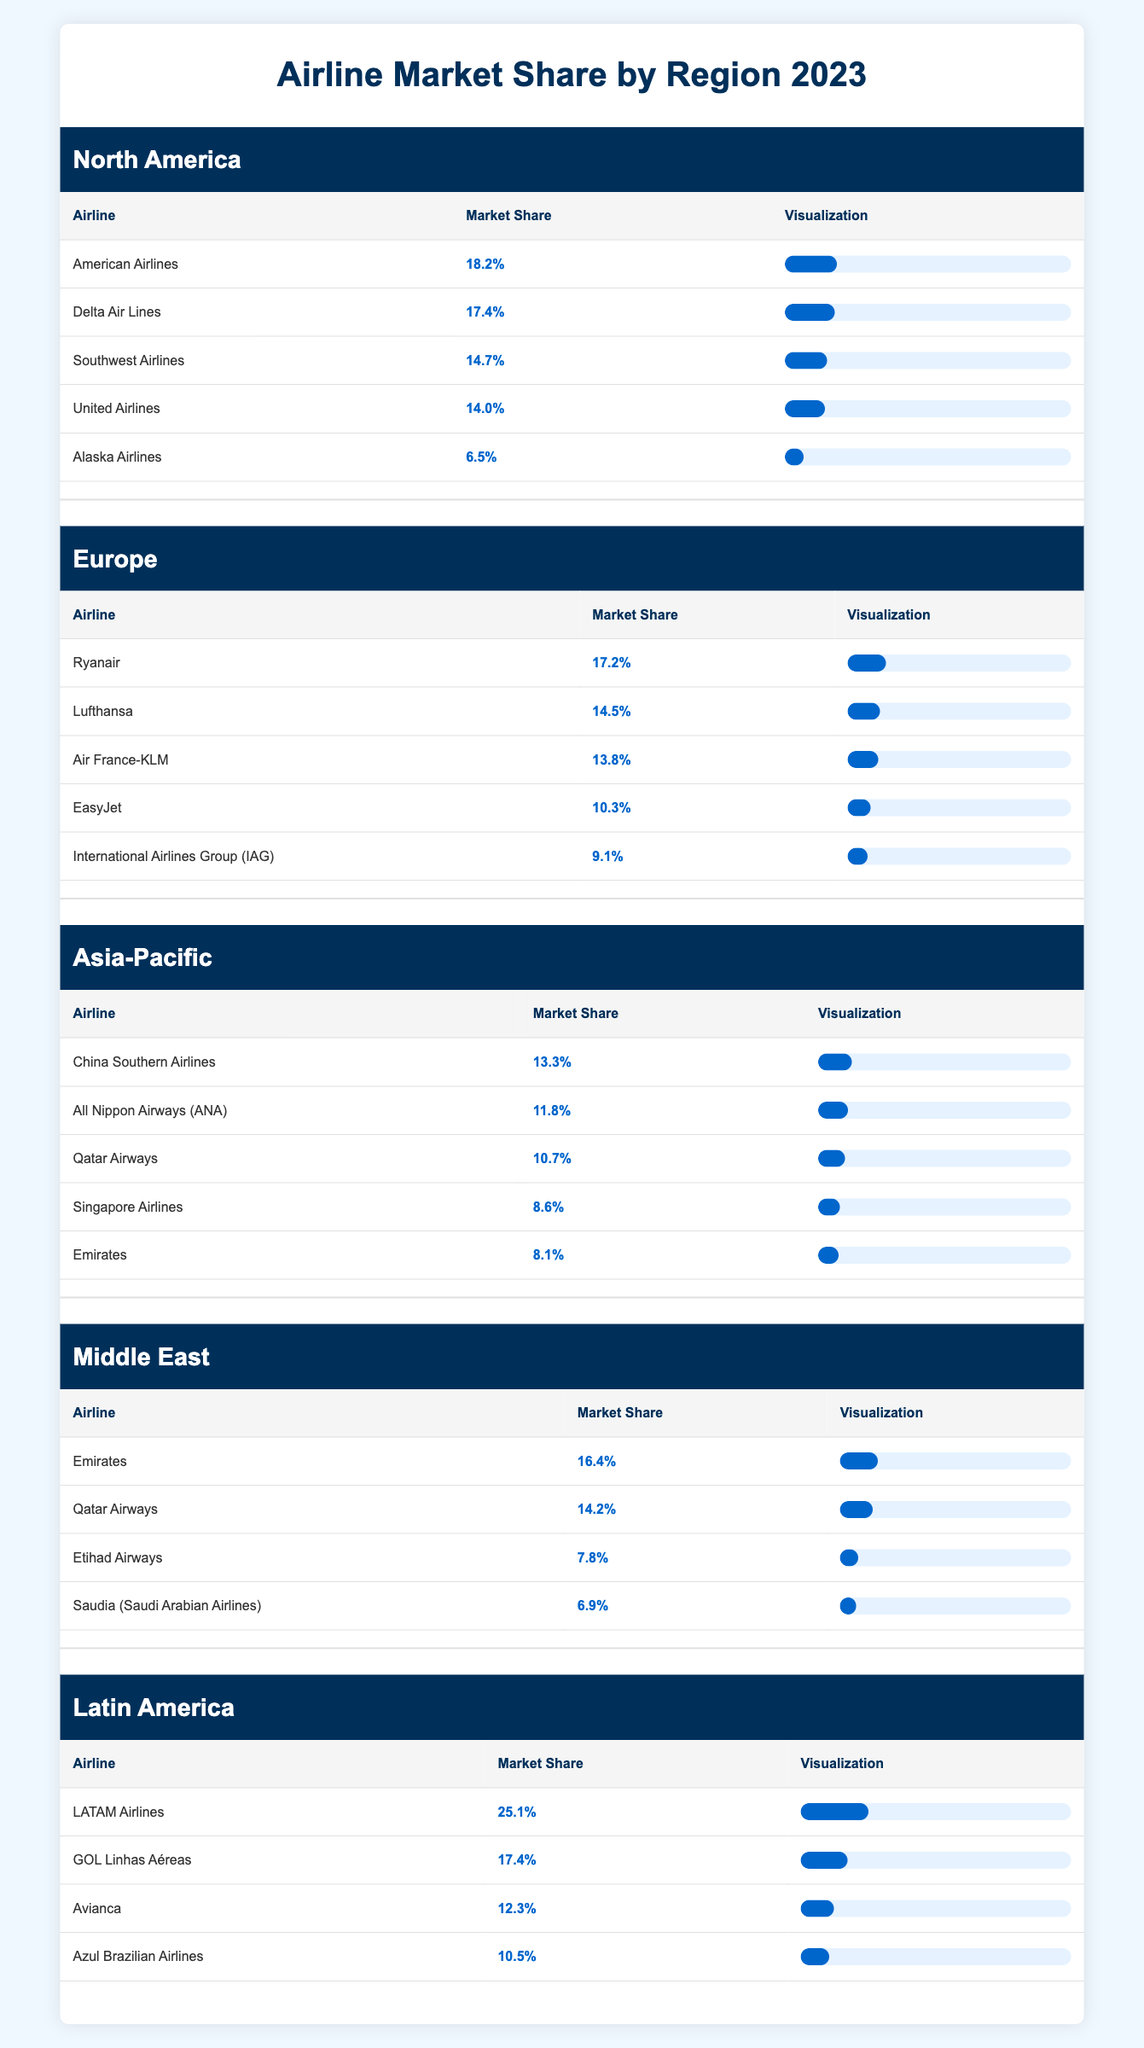What is the market share of American Airlines in North America? From the table under the North America region, American Airlines has a market share of 18.2%.
Answer: 18.2% Which airline has the highest market share in Latin America? The airline with the highest market share in Latin America is LATAM Airlines, with a market share of 25.1%.
Answer: LATAM Airlines Is Qatar Airways one of the top three airlines in the Middle East by market share? In the Middle East region, Qatar Airways has a market share of 14.2%, which places it second after Emirates and above Etihad Airways and Saudia. Therefore, it is indeed in the top three.
Answer: Yes What is the combined market share of the top two airlines in Europe? The top two airlines in Europe, Ryanair and Lufthansa, have market shares of 17.2% and 14.5%, respectively. Their combined market share is 17.2% + 14.5% = 31.7%.
Answer: 31.7% How does the market share of Emirates in the Middle East compare to its share in the Asia-Pacific region? Emirates has a market share of 16.4% in the Middle East and 8.1% in the Asia-Pacific region. This shows that its market share is significantly higher in the Middle East (16.4% > 8.1%).
Answer: Higher in the Middle East What is the average market share of airlines in the Asia-Pacific region? The airlines listed in the Asia-Pacific include China Southern Airlines (13.3%), All Nippon Airways (11.8%), Qatar Airways (10.7%), Singapore Airlines (8.6%), and Emirates (8.1%). Adding these gives a total of 52.5%. Dividing by 5 (the number of airlines) gives an average of 52.5% / 5 = 10.5%.
Answer: 10.5% Which region has the lowest market share for its leading airline, and what is that percentage? By examining the regions, Asia-Pacific has China Southern Airlines leading with a market share of 13.3%, while the leading airline in the Middle East is Emirates at 16.4%, which is higher; thus, Asia-Pacific has the lowest leading airline market share.
Answer: Asia-Pacific, 13.3% How many airlines in Europe have a market share of more than 10%? From the European section of the table, Ryanair (17.2%), Lufthansa (14.5%), Air France-KLM (13.8%), and EasyJet (10.3%) have market shares above 10%. Counting these shows there are four airlines above 10%.
Answer: Four airlines Which airline has a greater market share, United Airlines in North America or EasyJet in Europe? United Airlines has a market share of 14.0% in North America, while EasyJet has a market share of 10.3% in Europe. Since 14.0% is greater than 10.3%, United Airlines has a greater market share.
Answer: United Airlines 